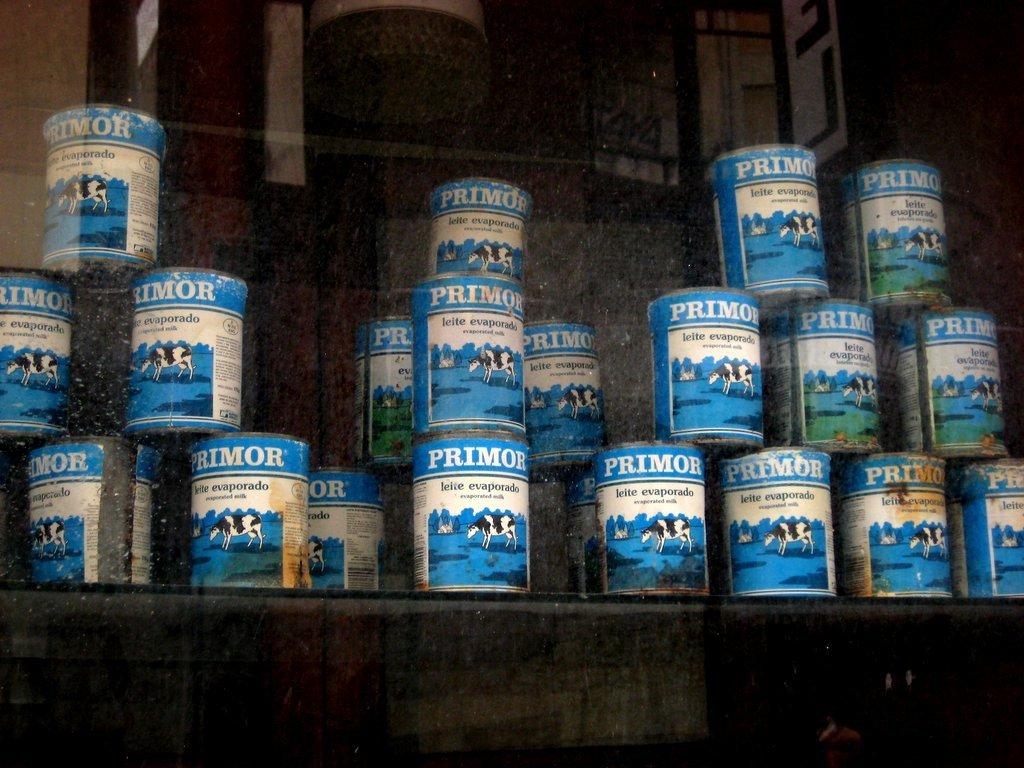What objects are on the rack in the image? There are boxes on a rack in the image. What can be seen behind the rack in the image? There is a wall visible in the image. Where might this image have been taken? The image might have been taken in a shop, given the presence of boxes on a rack. What type of wool is being used to create the divisions between the boxes in the image? There are no divisions between the boxes in the image, nor is there any wool present. 